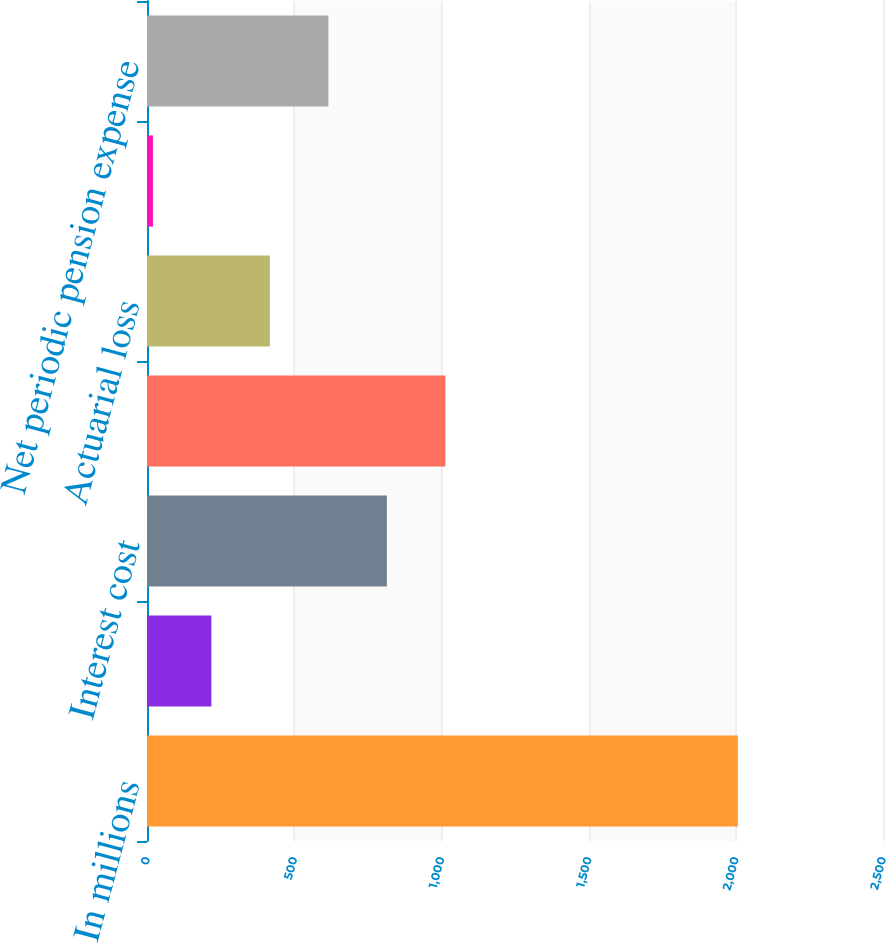<chart> <loc_0><loc_0><loc_500><loc_500><bar_chart><fcel>In millions<fcel>Service cost<fcel>Interest cost<fcel>Expectedreturnonplanassets<fcel>Actuarial loss<fcel>Amortization of prior service<fcel>Net periodic pension expense<nl><fcel>2007<fcel>218.7<fcel>814.8<fcel>1013.5<fcel>417.4<fcel>20<fcel>616.1<nl></chart> 